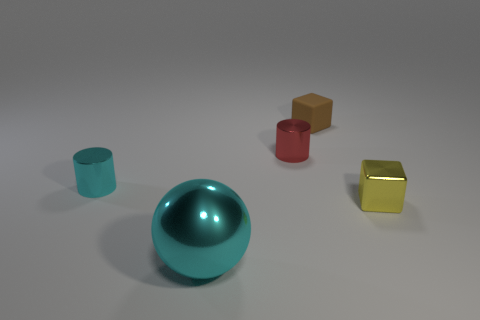What is the material of the object that is both in front of the cyan metallic cylinder and to the right of the big cyan shiny sphere? The object in question appears to be a smaller, golden cube with a reflective surface, suggesting that it is likely made of a polished metal. Its position is directly in front of the cyan cylinder and to the immediate right of the large cyan sphere. 